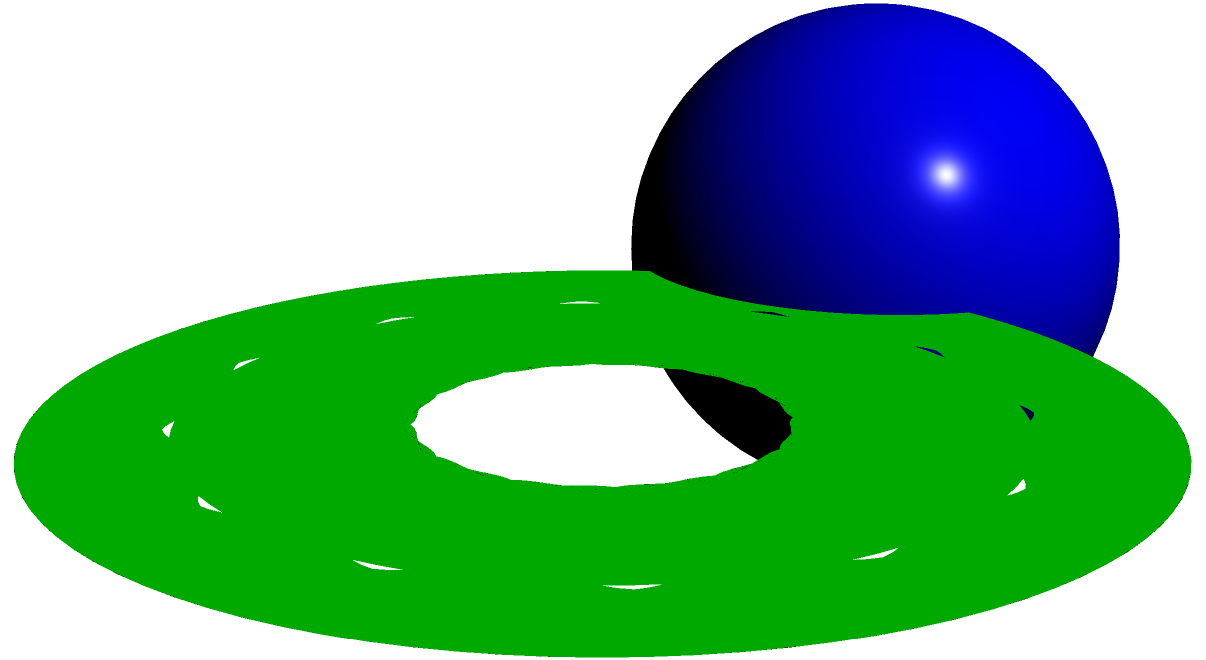In the context of creating personalized lesson plans for a child undergoing medical treatment, you want to introduce the concept of topology and Euler characteristic. Using the provided diagram showing a sphere, a torus, and a Klein bottle, explain how these surfaces differ in terms of their Euler characteristic. Which of these surfaces has an Euler characteristic of 2? To answer this question, let's break down the concept of Euler characteristic and how it applies to each surface:

1. Euler characteristic:
   The Euler characteristic (χ) is calculated using the formula:
   $$χ = V - E + F$$
   where V is the number of vertices, E is the number of edges, and F is the number of faces in a polyhedron approximation of the surface.

2. Sphere:
   - A sphere can be approximated by a tetrahedron (simplest polyhedron).
   - Tetrahedron: 4 vertices, 6 edges, 4 faces
   - $$χ_{sphere} = 4 - 6 + 4 = 2$$

3. Torus:
   - A torus has a hole, which affects its Euler characteristic.
   - For a torus: $$χ_{torus} = 0$$

4. Klein bottle:
   - A Klein bottle is a non-orientable surface.
   - For a Klein bottle: $$χ_{Klein bottle} = 0$$

5. Comparison:
   - Sphere: χ = 2
   - Torus: χ = 0
   - Klein bottle: χ = 0

Therefore, among the given surfaces, only the sphere has an Euler characteristic of 2.

This concept can be integrated into a lesson plan to help the child understand basic topology while relating it to familiar shapes, making the learning process more engaging during their treatment.
Answer: Sphere 